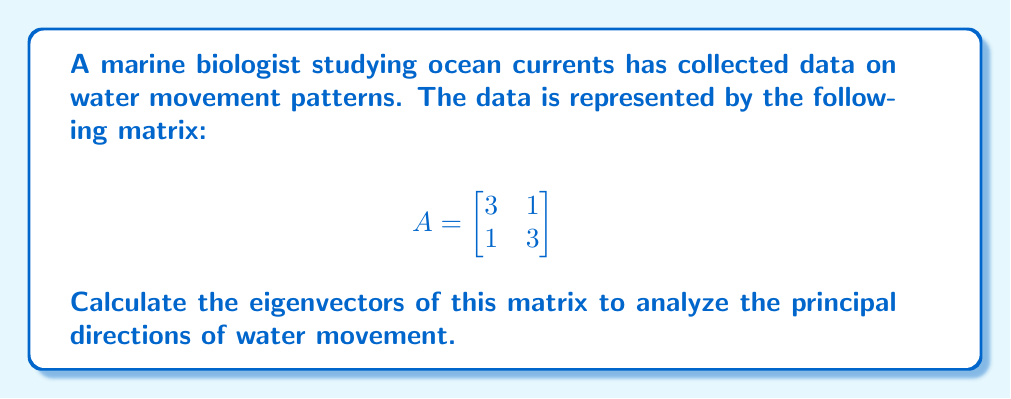Could you help me with this problem? To find the eigenvectors, we follow these steps:

1) First, we need to find the eigenvalues by solving the characteristic equation:
   $$det(A - \lambda I) = 0$$

2) Expand the determinant:
   $$\begin{vmatrix}
   3-\lambda & 1 \\
   1 & 3-\lambda
   \end{vmatrix} = 0$$

3) Solve the resulting quadratic equation:
   $$(3-\lambda)^2 - 1 = 0$$
   $$\lambda^2 - 6\lambda + 8 = 0$$
   $$(\lambda - 4)(\lambda - 2) = 0$$

4) The eigenvalues are $\lambda_1 = 4$ and $\lambda_2 = 2$

5) For each eigenvalue, we solve $(A - \lambda I)v = 0$ to find the corresponding eigenvector:

   For $\lambda_1 = 4$:
   $$\begin{bmatrix}
   -1 & 1 \\
   1 & -1
   \end{bmatrix}\begin{bmatrix}
   v_1 \\
   v_2
   \end{bmatrix} = \begin{bmatrix}
   0 \\
   0
   \end{bmatrix}$$

   This gives us $v_1 = v_2$, so an eigenvector is $\begin{bmatrix} 1 \\ 1 \end{bmatrix}$

   For $\lambda_2 = 2$:
   $$\begin{bmatrix}
   1 & 1 \\
   1 & 1
   \end{bmatrix}\begin{bmatrix}
   v_1 \\
   v_2
   \end{bmatrix} = \begin{bmatrix}
   0 \\
   0
   \end{bmatrix}$$

   This gives us $v_1 = -v_2$, so an eigenvector is $\begin{bmatrix} 1 \\ -1 \end{bmatrix}$

6) Therefore, the eigenvectors are $\begin{bmatrix} 1 \\ 1 \end{bmatrix}$ and $\begin{bmatrix} 1 \\ -1 \end{bmatrix}$
Answer: $\begin{bmatrix} 1 \\ 1 \end{bmatrix}$ and $\begin{bmatrix} 1 \\ -1 \end{bmatrix}$ 